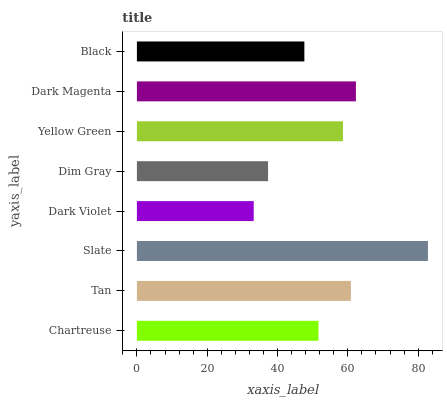Is Dark Violet the minimum?
Answer yes or no. Yes. Is Slate the maximum?
Answer yes or no. Yes. Is Tan the minimum?
Answer yes or no. No. Is Tan the maximum?
Answer yes or no. No. Is Tan greater than Chartreuse?
Answer yes or no. Yes. Is Chartreuse less than Tan?
Answer yes or no. Yes. Is Chartreuse greater than Tan?
Answer yes or no. No. Is Tan less than Chartreuse?
Answer yes or no. No. Is Yellow Green the high median?
Answer yes or no. Yes. Is Chartreuse the low median?
Answer yes or no. Yes. Is Dark Violet the high median?
Answer yes or no. No. Is Dark Violet the low median?
Answer yes or no. No. 